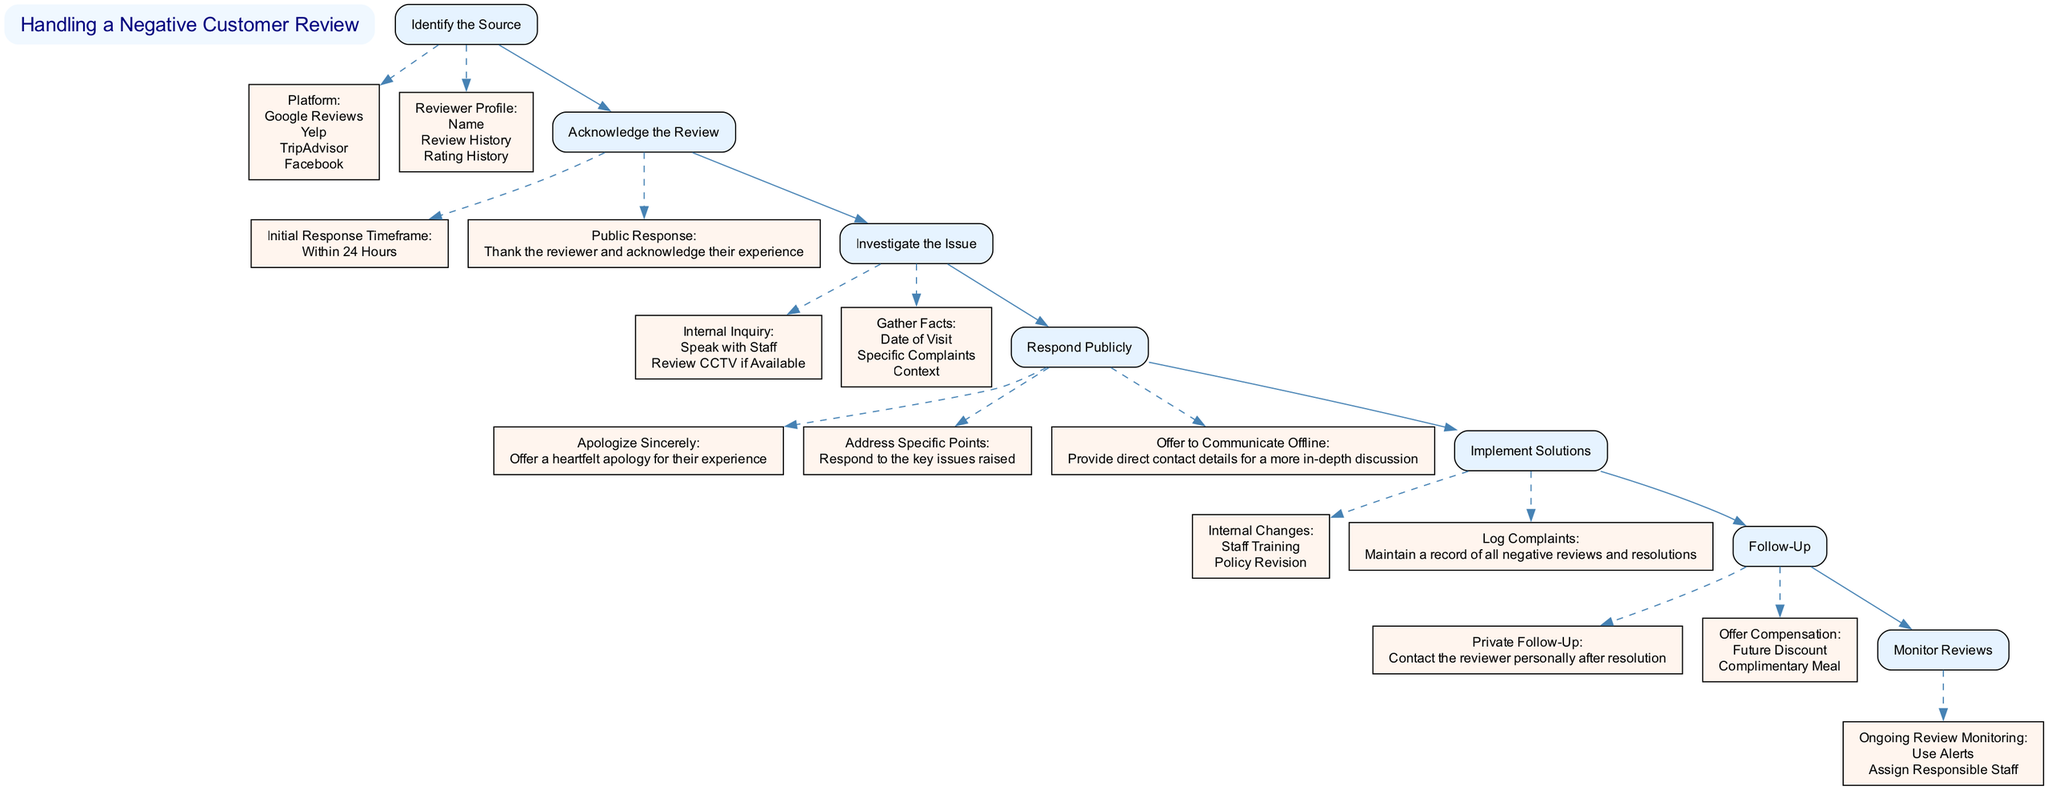What is the first step in handling a negative customer review? The first step in the flow chart is "Identify the Source". This is clearly displayed at the top of the diagram as the starting point.
Answer: Identify the Source How many main steps are there in the process? By counting the nodes connected directly to the title node, we see there are six main steps in total in the diagram.
Answer: Six What does the "Investigate the Issue" step entail? This step includes two sub-steps: "Internal Inquiry", which has actions such as "Speak with Staff" and "Review CCTV if Available", and "Gather Facts", which specifies what information to collect regarding the complaint.
Answer: Internal Inquiry, Gather Facts In what timeframe should the initial response to a negative review be made? The diagram states that the initial response must be made "Within 24 Hours". This information is clearly outlined in the "Acknowledge the Review" section.
Answer: Within 24 Hours What are the two options for compensation offered in the "Follow-Up" step? The "Offer Compensation" node includes two options: "Future Discount" and "Complimentary Meal". These options are specified in the "Follow-Up" section of the diagram.
Answer: Future Discount, Complimentary Meal What is the purpose of the "Monitor Reviews" step? This step is focused on ensuring ongoing oversight of customer reviews. It includes actions such as "Use Alerts" and "Assign Responsible Staff" to manage the review process effectively.
Answer: Ongoing review monitoring After responding publicly to the review, what is recommended for further communication? The recommendation is to "Offer to Communicate Offline", which suggests providing direct contact details for a more in-depth discussion about the review. This encourages resolution outside of public view.
Answer: Offer to Communicate Offline 